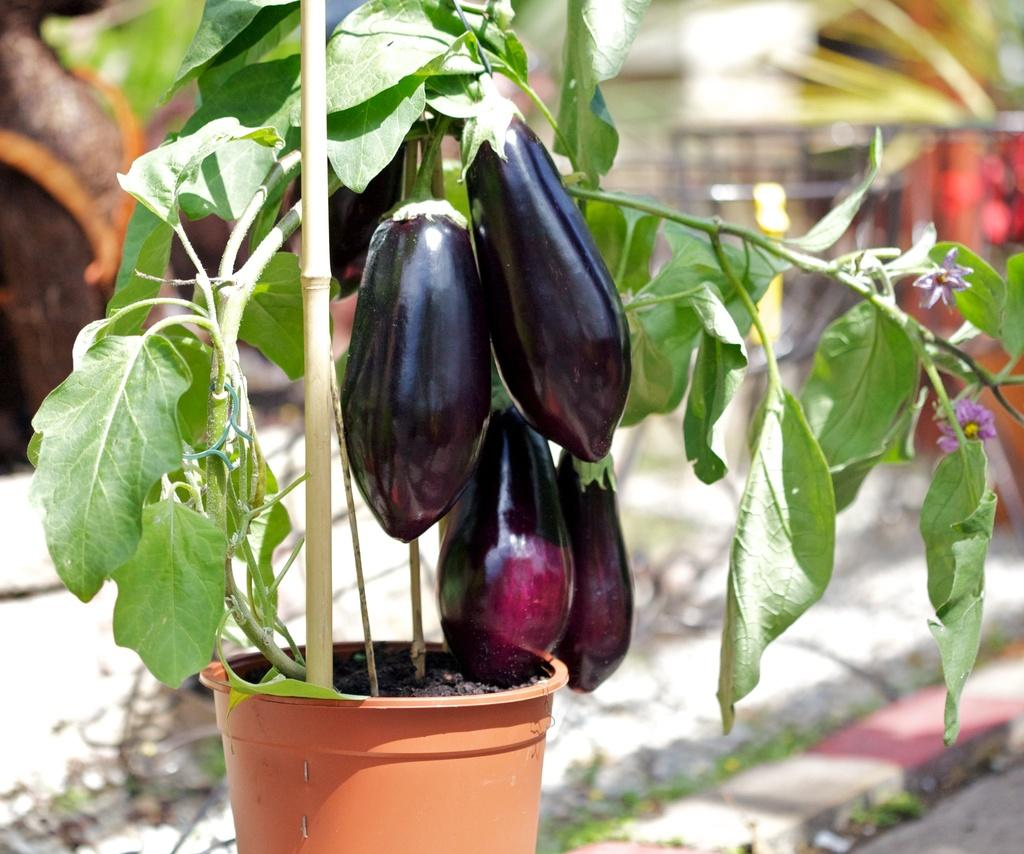What type of plant is in the foreground of the image? There is a brinjal plant in the foreground of the image. Can you describe the background of the image? The background of the image is blurred. What type of soap is being used to clean the prison in the image? There is no soap, prison, or cleaning activity present in the image; it features a brinjal plant in the foreground and a blurred background. 